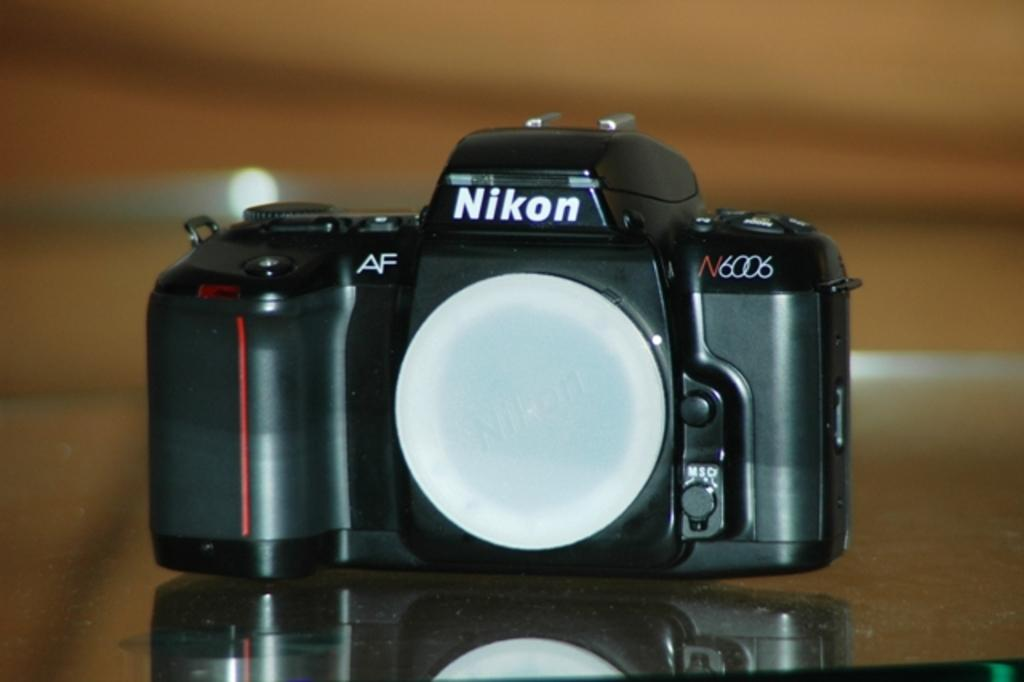<image>
Provide a brief description of the given image. An old fashioned camera with the word Nikon on it. 